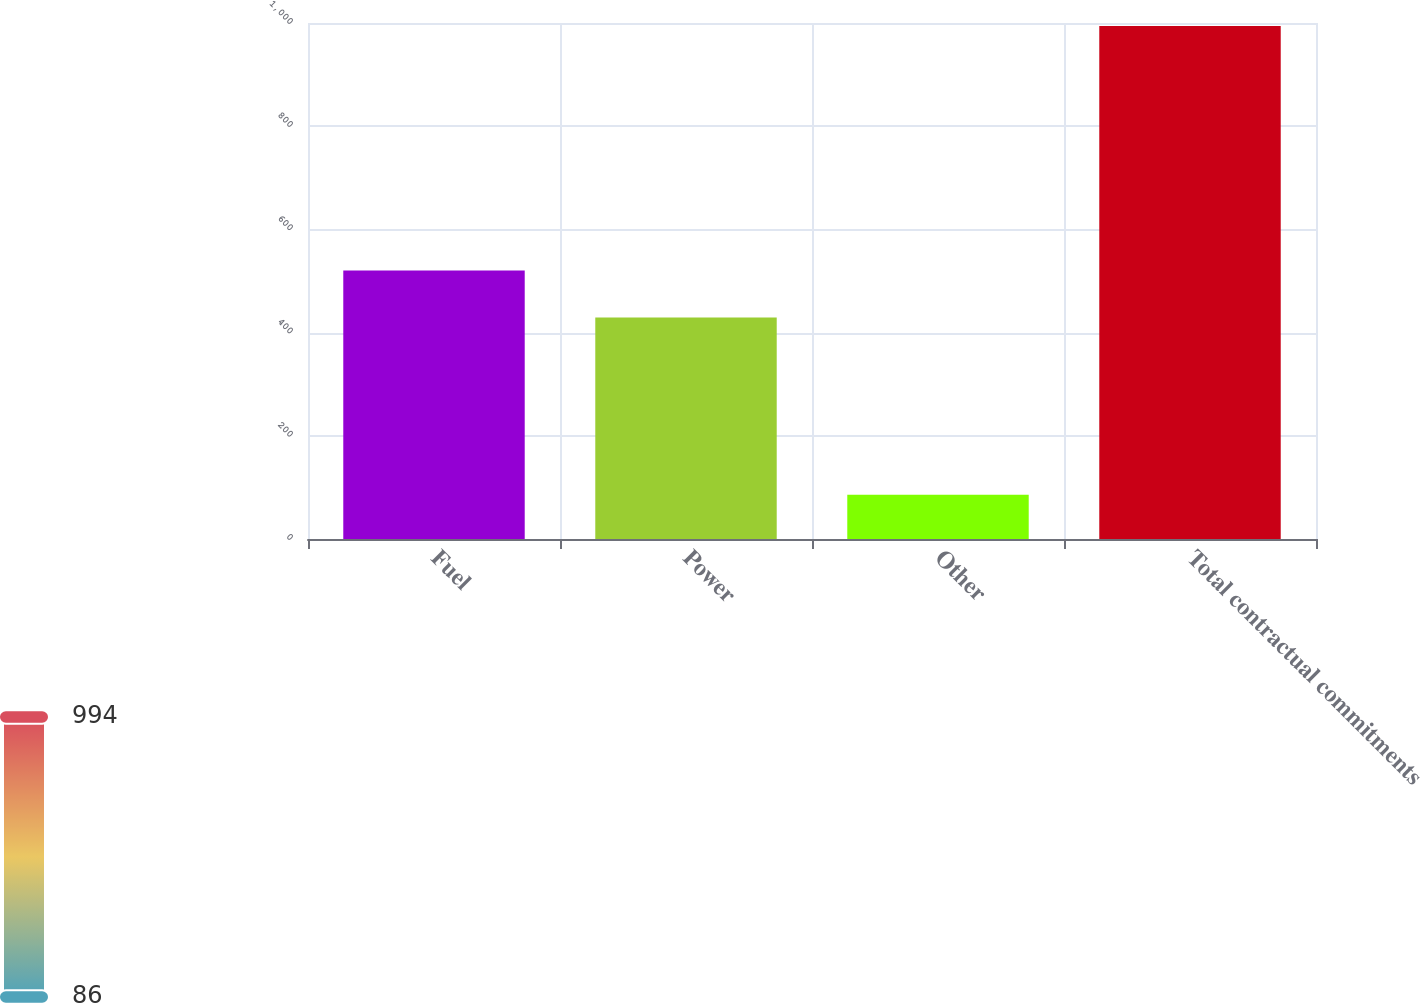<chart> <loc_0><loc_0><loc_500><loc_500><bar_chart><fcel>Fuel<fcel>Power<fcel>Other<fcel>Total contractual commitments<nl><fcel>520.22<fcel>429.4<fcel>85.8<fcel>994<nl></chart> 